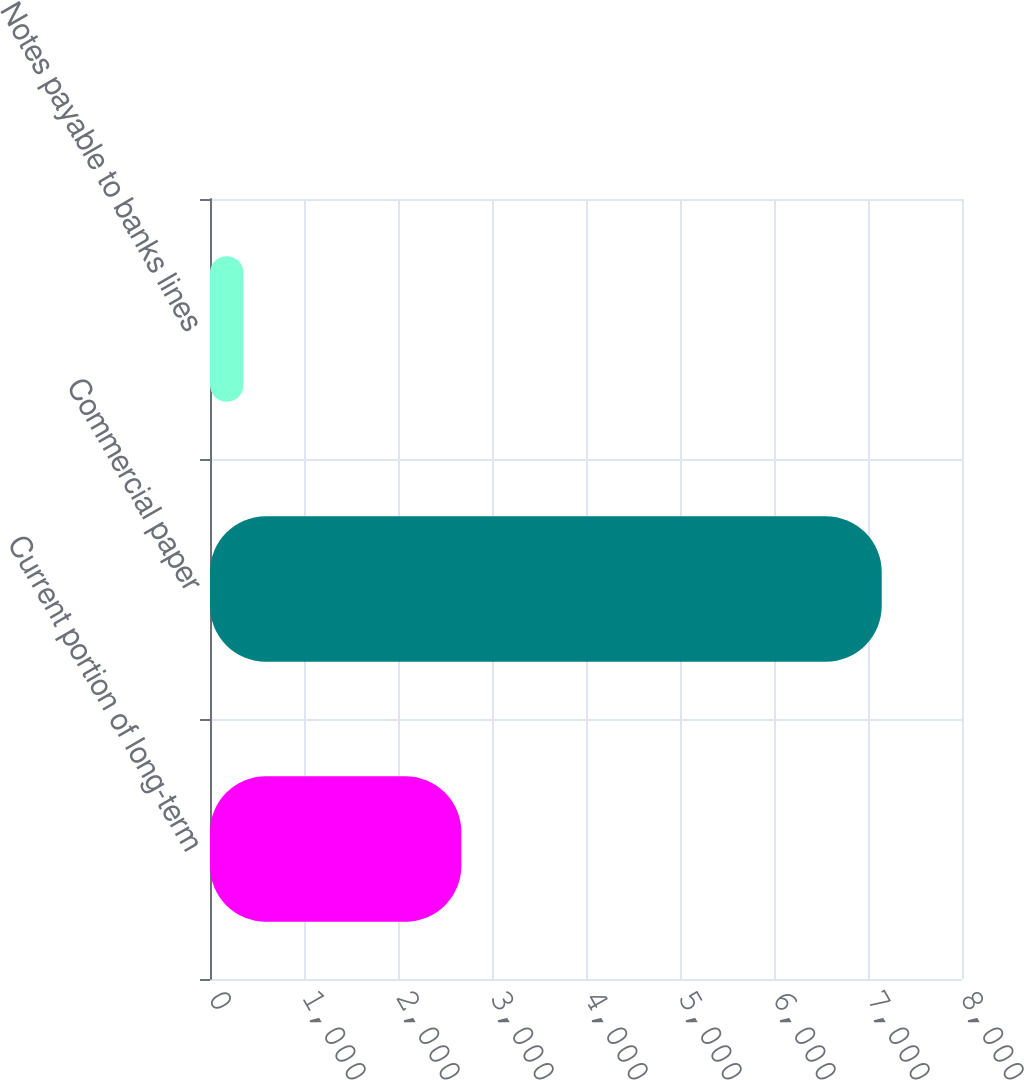Convert chart to OTSL. <chart><loc_0><loc_0><loc_500><loc_500><bar_chart><fcel>Current portion of long-term<fcel>Commercial paper<fcel>Notes payable to banks lines<nl><fcel>2674<fcel>7146<fcel>356<nl></chart> 